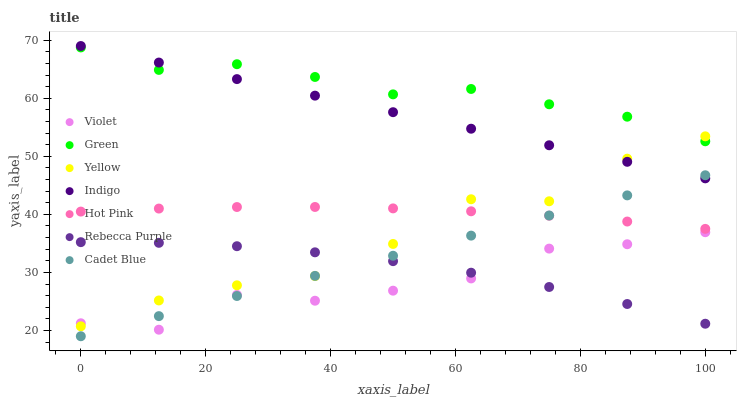Does Violet have the minimum area under the curve?
Answer yes or no. Yes. Does Green have the maximum area under the curve?
Answer yes or no. Yes. Does Indigo have the minimum area under the curve?
Answer yes or no. No. Does Indigo have the maximum area under the curve?
Answer yes or no. No. Is Cadet Blue the smoothest?
Answer yes or no. Yes. Is Yellow the roughest?
Answer yes or no. Yes. Is Indigo the smoothest?
Answer yes or no. No. Is Indigo the roughest?
Answer yes or no. No. Does Cadet Blue have the lowest value?
Answer yes or no. Yes. Does Indigo have the lowest value?
Answer yes or no. No. Does Indigo have the highest value?
Answer yes or no. Yes. Does Hot Pink have the highest value?
Answer yes or no. No. Is Cadet Blue less than Green?
Answer yes or no. Yes. Is Green greater than Rebecca Purple?
Answer yes or no. Yes. Does Violet intersect Cadet Blue?
Answer yes or no. Yes. Is Violet less than Cadet Blue?
Answer yes or no. No. Is Violet greater than Cadet Blue?
Answer yes or no. No. Does Cadet Blue intersect Green?
Answer yes or no. No. 